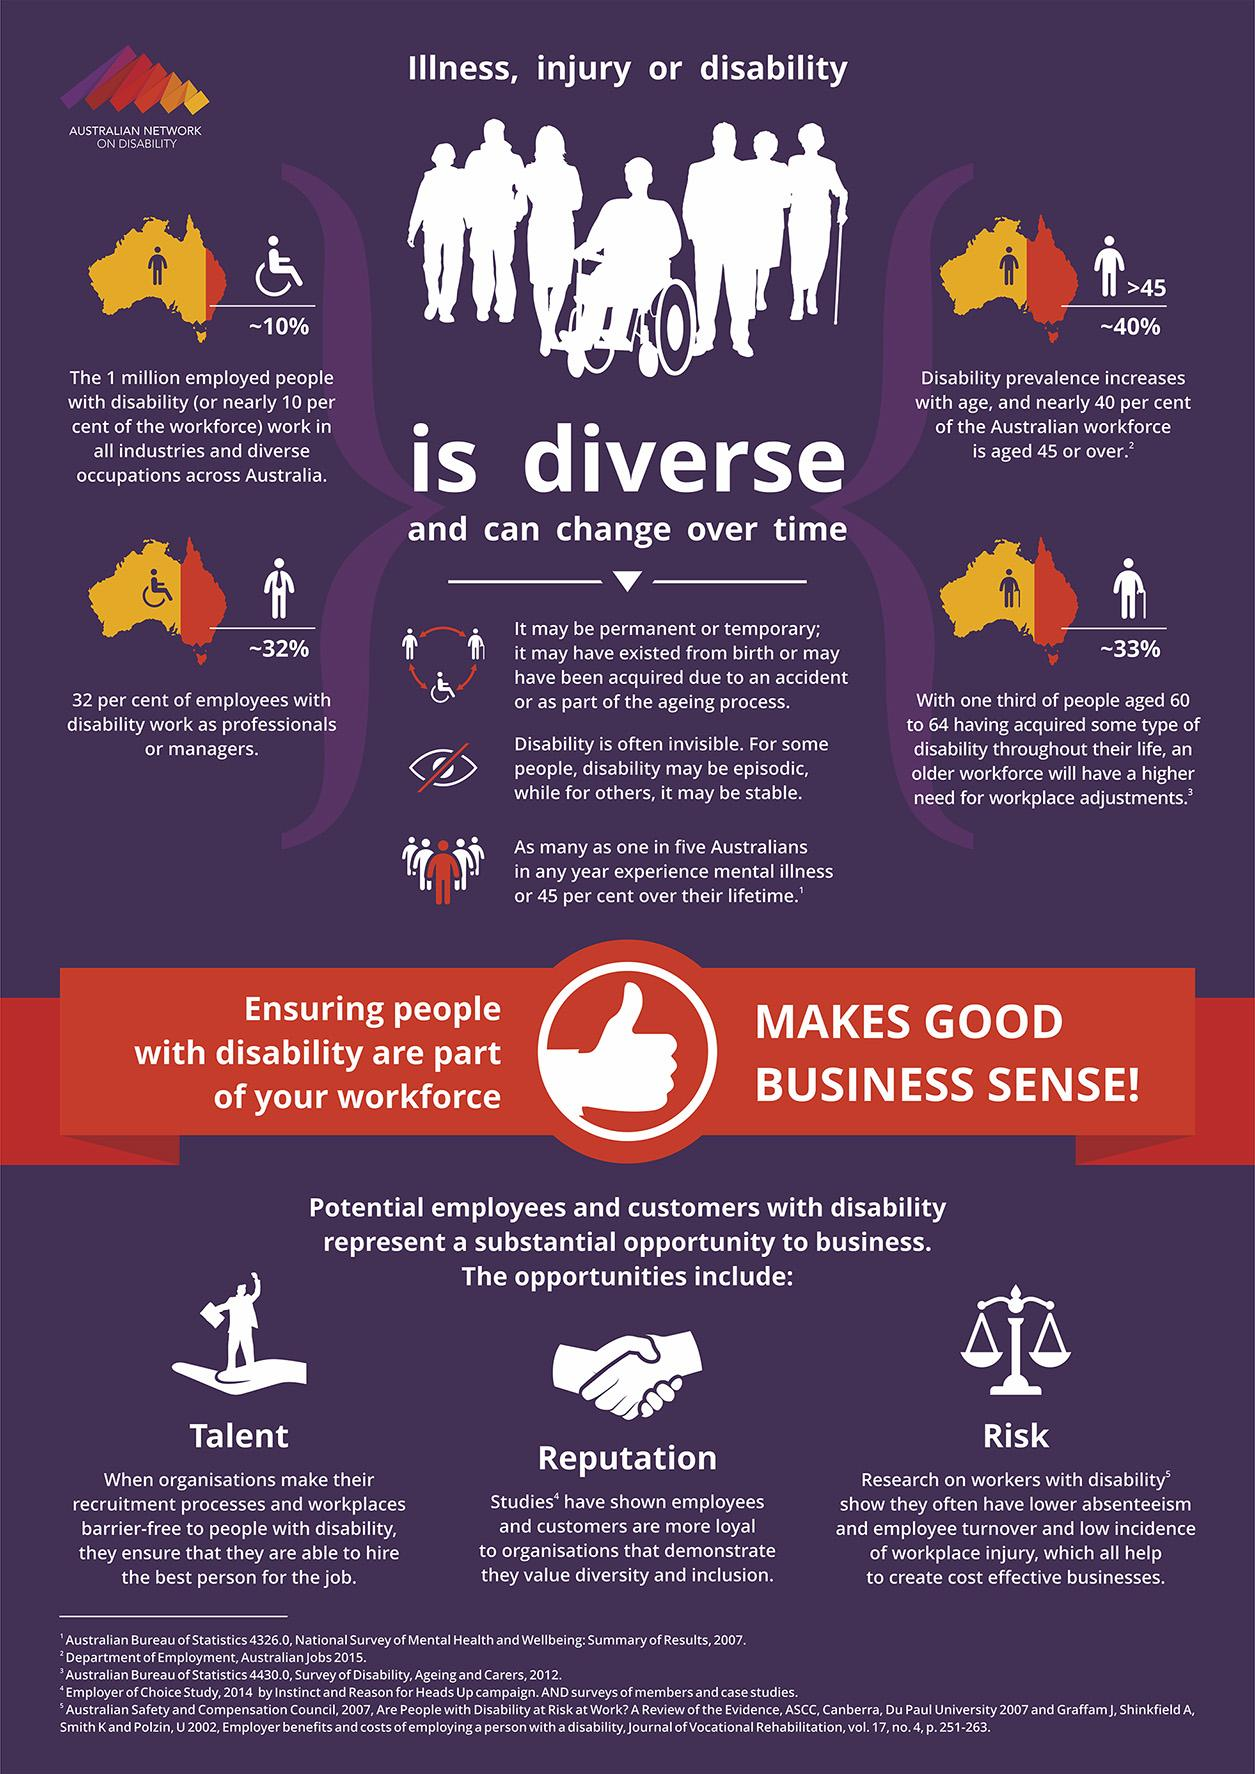Mention a couple of crucial points in this snapshot. Diversity encompasses a wide range of characteristics that can change over time, such as illness, injury, or disability. In Australia, approximately 10% of the workforce with disabilities is present. According to a recent survey, 68% of employees with disabilities do not work as professionals or managers. 